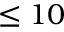Convert formula to latex. <formula><loc_0><loc_0><loc_500><loc_500>\leq 1 0</formula> 